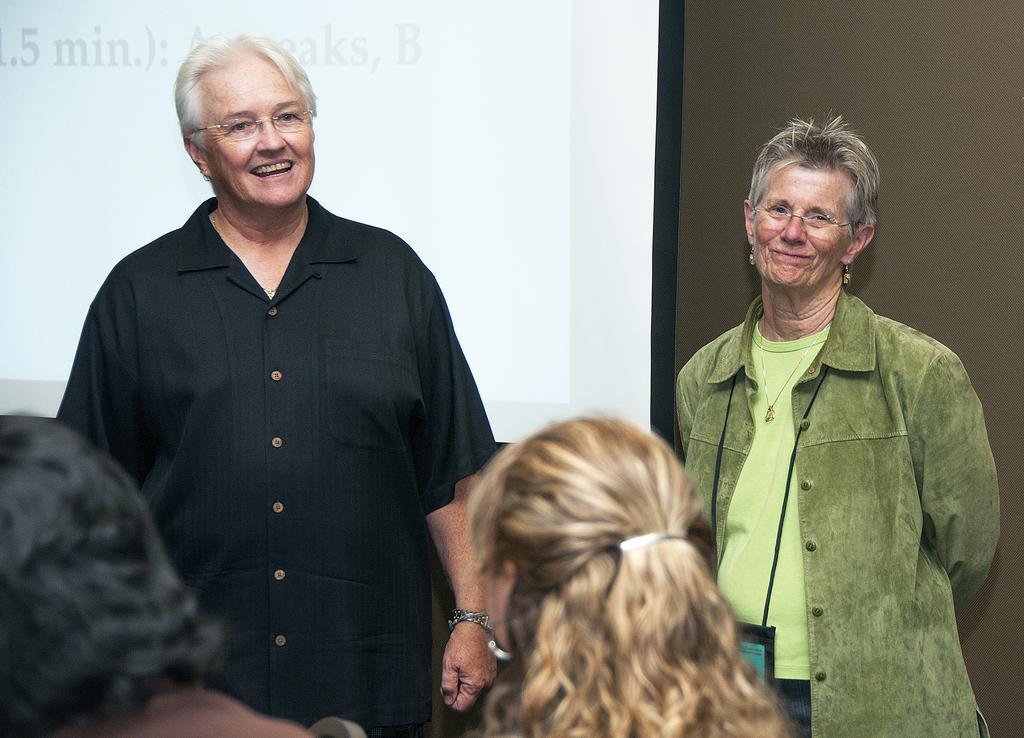In one or two sentences, can you explain what this image depicts? In this picture I can observe women in the middle of the picture. Behind them I can observe projector display screen. In the background I can observe wall. 